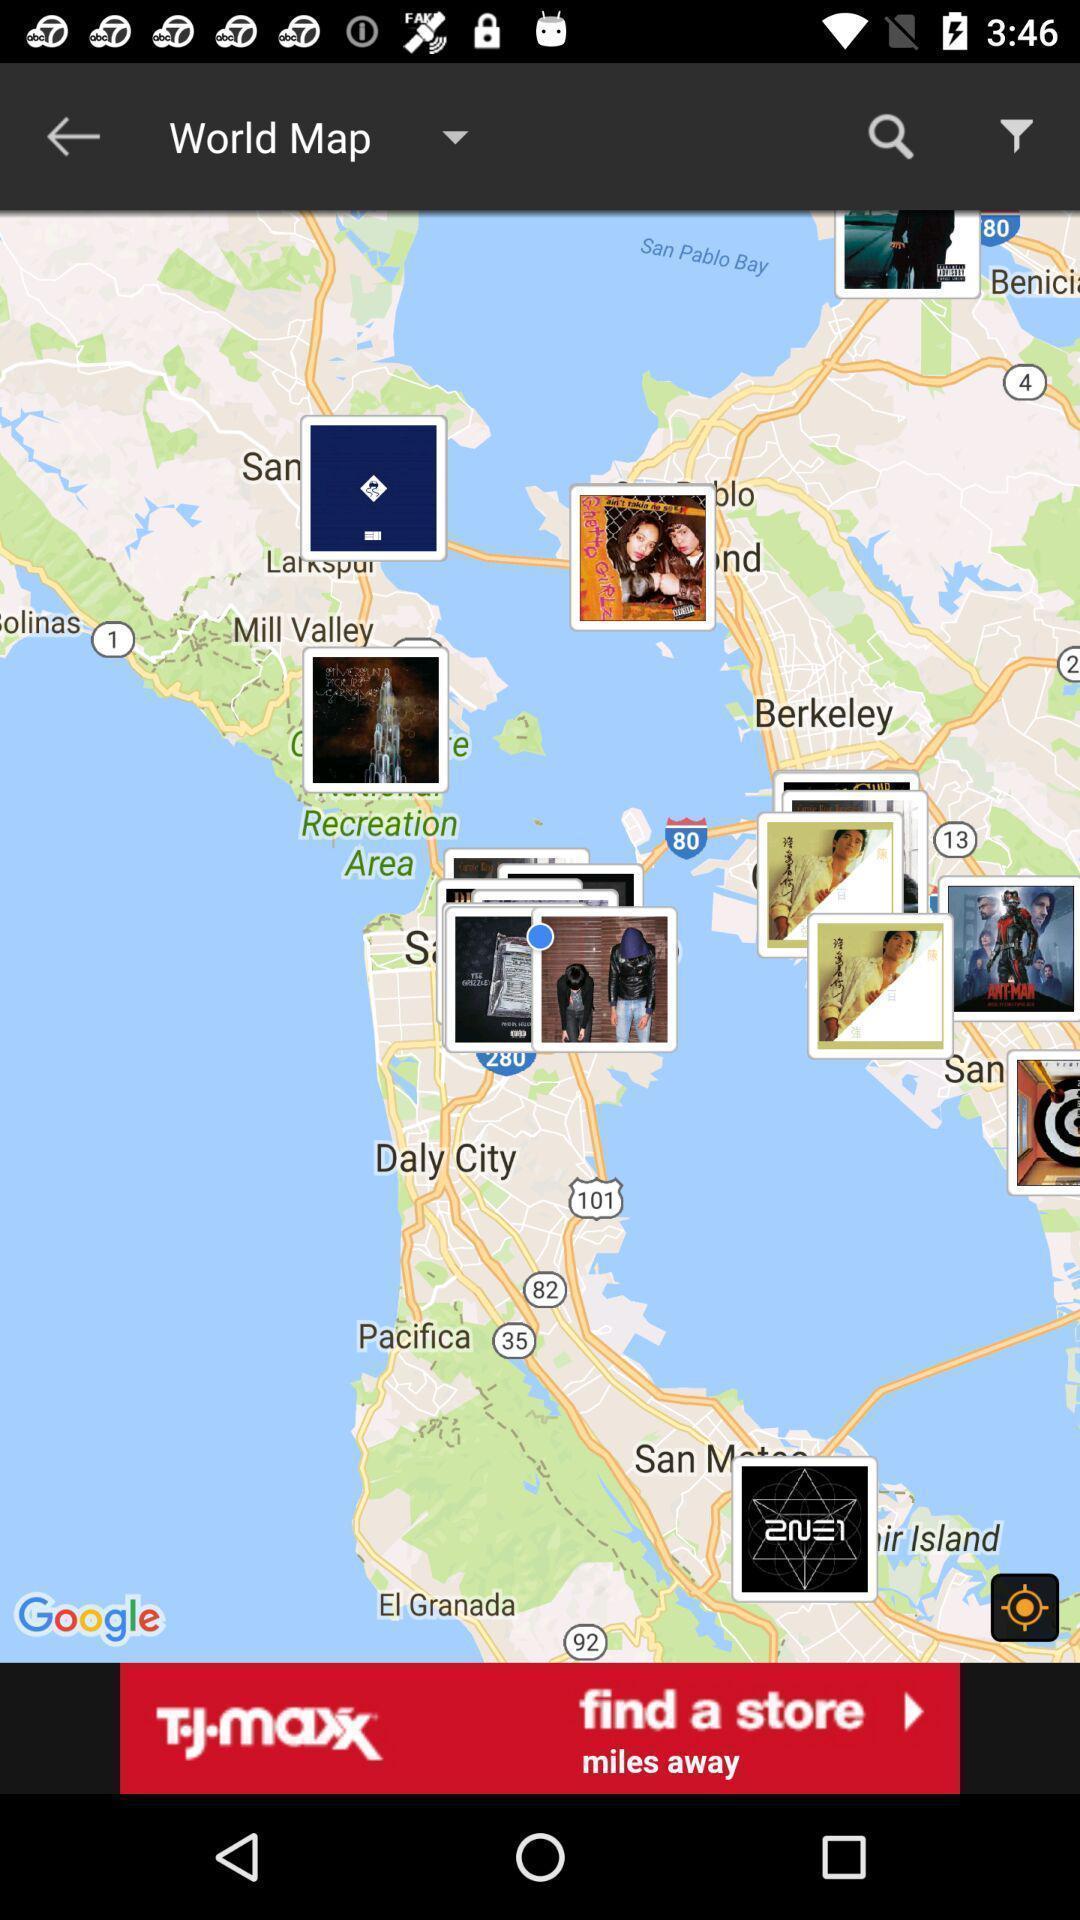Provide a description of this screenshot. Various location images displayed of map navigation app. 